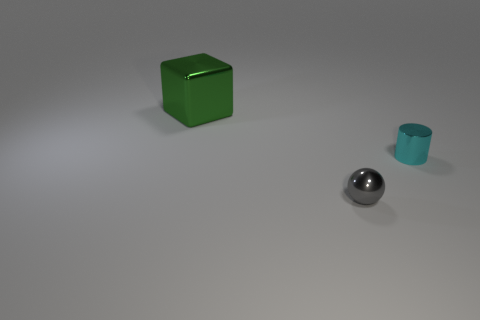Are there fewer metallic cylinders that are behind the small cyan metal cylinder than large green cubes?
Make the answer very short. Yes. Are there any other things that have the same size as the cube?
Offer a terse response. No. What number of things are shiny objects that are in front of the big green shiny cube or small objects in front of the tiny cyan metallic cylinder?
Keep it short and to the point. 2. Is there another cyan cylinder of the same size as the metallic cylinder?
Your answer should be compact. No. Are there any gray metal balls that are on the left side of the object on the left side of the tiny gray metal ball?
Your response must be concise. No. There is a tiny shiny object that is in front of the cyan metal thing; is it the same shape as the green metallic thing?
Your answer should be very brief. No. What shape is the big green metal thing?
Keep it short and to the point. Cube. What number of small spheres are the same material as the green cube?
Provide a succinct answer. 1. How many small metallic objects are there?
Make the answer very short. 2. What color is the metallic object to the left of the tiny thing that is to the left of the tiny thing that is behind the gray sphere?
Your answer should be very brief. Green. 